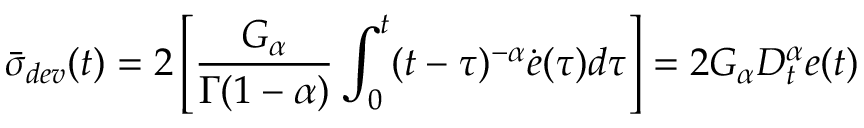<formula> <loc_0><loc_0><loc_500><loc_500>\bar { \sigma } _ { d e v } ( t ) = 2 \left [ \frac { G _ { \alpha } } { \Gamma ( 1 - \alpha ) } \int _ { 0 } ^ { t } ( t - \tau ) ^ { - \alpha } \dot { e } ( \tau ) d \tau \right ] = 2 G _ { \alpha } D _ { t } ^ { \alpha } e ( t )</formula> 